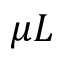<formula> <loc_0><loc_0><loc_500><loc_500>\mu L</formula> 